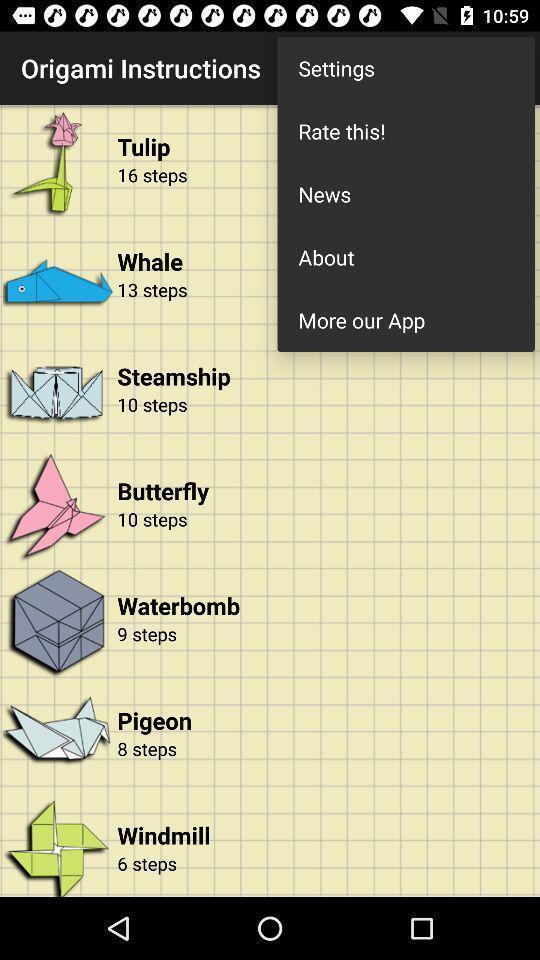Tell me about the visual elements in this screen capture. Pop-up showing the multiple options. 